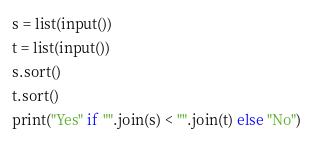Convert code to text. <code><loc_0><loc_0><loc_500><loc_500><_Python_>s = list(input())
t = list(input())
s.sort()
t.sort()
print("Yes" if "".join(s) < "".join(t) else "No")</code> 